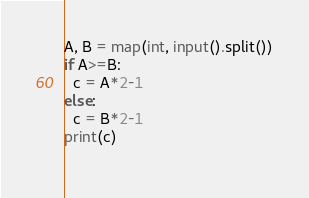Convert code to text. <code><loc_0><loc_0><loc_500><loc_500><_Python_>A, B = map(int, input().split())
if A>=B:
  c = A*2-1
else:
  c = B*2-1
print(c)
  
</code> 